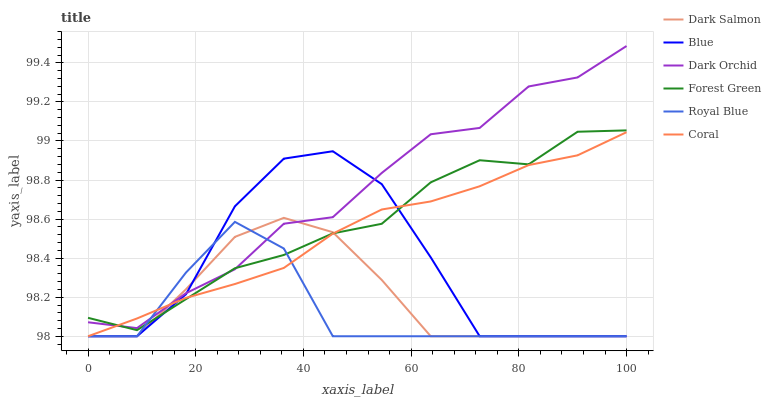Does Royal Blue have the minimum area under the curve?
Answer yes or no. Yes. Does Dark Orchid have the maximum area under the curve?
Answer yes or no. Yes. Does Coral have the minimum area under the curve?
Answer yes or no. No. Does Coral have the maximum area under the curve?
Answer yes or no. No. Is Coral the smoothest?
Answer yes or no. Yes. Is Blue the roughest?
Answer yes or no. Yes. Is Dark Salmon the smoothest?
Answer yes or no. No. Is Dark Salmon the roughest?
Answer yes or no. No. Does Blue have the lowest value?
Answer yes or no. Yes. Does Dark Orchid have the lowest value?
Answer yes or no. No. Does Dark Orchid have the highest value?
Answer yes or no. Yes. Does Coral have the highest value?
Answer yes or no. No. Does Blue intersect Coral?
Answer yes or no. Yes. Is Blue less than Coral?
Answer yes or no. No. Is Blue greater than Coral?
Answer yes or no. No. 